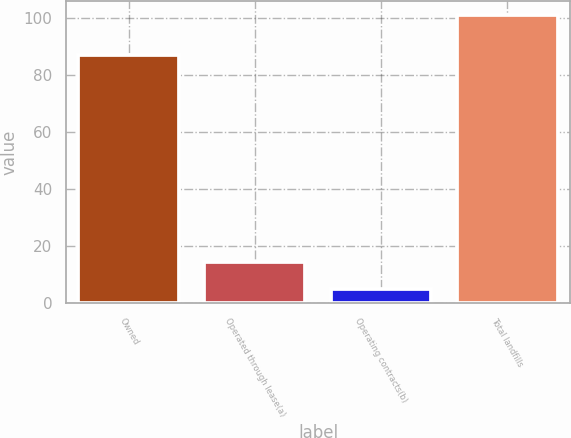Convert chart. <chart><loc_0><loc_0><loc_500><loc_500><bar_chart><fcel>Owned<fcel>Operated through lease(a)<fcel>Operating contracts(b)<fcel>Total landfills<nl><fcel>87<fcel>14.6<fcel>5<fcel>101<nl></chart> 